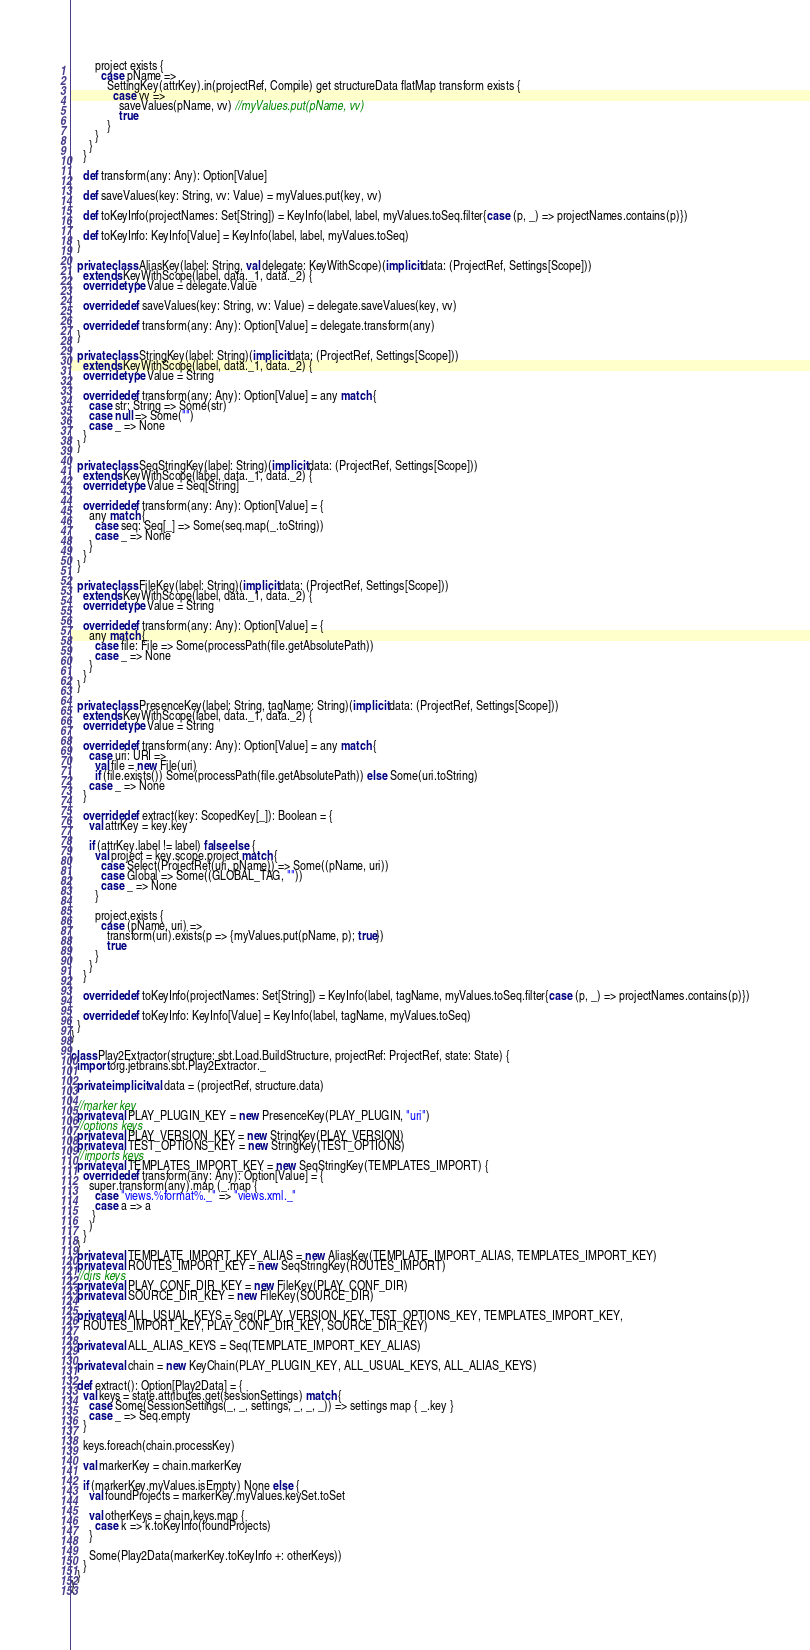<code> <loc_0><loc_0><loc_500><loc_500><_Scala_>
        project exists {
          case pName =>
            SettingKey(attrKey).in(projectRef, Compile) get structureData flatMap transform exists {
              case vv =>
                saveValues(pName, vv) //myValues.put(pName, vv)
                true
            }
        }
      }
    }

    def transform(any: Any): Option[Value]

    def saveValues(key: String, vv: Value) = myValues.put(key, vv)

    def toKeyInfo(projectNames: Set[String]) = KeyInfo(label, label, myValues.toSeq.filter{case (p, _) => projectNames.contains(p)})

    def toKeyInfo: KeyInfo[Value] = KeyInfo(label, label, myValues.toSeq)
  }

  private class AliasKey(label: String, val delegate: KeyWithScope)(implicit data: (ProjectRef, Settings[Scope]))
    extends KeyWithScope(label, data._1, data._2) {
    override type Value = delegate.Value

    override def saveValues(key: String, vv: Value) = delegate.saveValues(key, vv)

    override def transform(any: Any): Option[Value] = delegate.transform(any)
  }

  private class StringKey(label: String)(implicit data: (ProjectRef, Settings[Scope]))
    extends KeyWithScope(label, data._1, data._2) {
    override type Value = String

    override def transform(any: Any): Option[Value] = any match {
      case str: String => Some(str)
      case null => Some("")
      case _ => None
    }
  }

  private class SeqStringKey(label: String)(implicit data: (ProjectRef, Settings[Scope]))
    extends KeyWithScope(label, data._1, data._2) {
    override type Value = Seq[String]

    override def transform(any: Any): Option[Value] = {
      any match {
        case seq: Seq[_] => Some(seq.map(_.toString))
        case _ => None
      }
    }
  }

  private class FileKey(label: String)(implicit data: (ProjectRef, Settings[Scope]))
    extends KeyWithScope(label, data._1, data._2) {
    override type Value = String

    override def transform(any: Any): Option[Value] = {
      any match {
        case file: File => Some(processPath(file.getAbsolutePath))
        case _ => None
      }
    }
  }

  private class PresenceKey(label: String, tagName: String)(implicit data: (ProjectRef, Settings[Scope]))
    extends KeyWithScope(label, data._1, data._2) {
    override type Value = String

    override def transform(any: Any): Option[Value] = any match {
      case uri: URI =>
        val file = new File(uri)
        if (file.exists()) Some(processPath(file.getAbsolutePath)) else Some(uri.toString)
      case _ => None
    }

    override def extract(key: ScopedKey[_]): Boolean = {
      val attrKey = key.key

      if (attrKey.label != label) false else {
        val project = key.scope.project match {
          case Select(ProjectRef(uri, pName)) => Some((pName, uri))
          case Global => Some((GLOBAL_TAG, ""))
          case _ => None
        }

        project.exists {
          case (pName, uri) =>
            transform(uri).exists(p => {myValues.put(pName, p); true})
            true
        }
      }
    }

    override def toKeyInfo(projectNames: Set[String]) = KeyInfo(label, tagName, myValues.toSeq.filter{case (p, _) => projectNames.contains(p)})

    override def toKeyInfo: KeyInfo[Value] = KeyInfo(label, tagName, myValues.toSeq)
  }
}

class Play2Extractor(structure: sbt.Load.BuildStructure, projectRef: ProjectRef, state: State) {
  import org.jetbrains.sbt.Play2Extractor._

  private implicit val data = (projectRef, structure.data)

  //marker key
  private val PLAY_PLUGIN_KEY = new PresenceKey(PLAY_PLUGIN, "uri")
  //options keys
  private val PLAY_VERSION_KEY = new StringKey(PLAY_VERSION)
  private val TEST_OPTIONS_KEY = new StringKey(TEST_OPTIONS)
  //imports keys
  private val TEMPLATES_IMPORT_KEY = new SeqStringKey(TEMPLATES_IMPORT) {
    override def transform(any: Any): Option[Value] = {
      super.transform(any).map (_.map {
        case "views.%format%._" => "views.xml._"
        case a => a
       }
      )
    }
  }
  private val TEMPLATE_IMPORT_KEY_ALIAS = new AliasKey(TEMPLATE_IMPORT_ALIAS, TEMPLATES_IMPORT_KEY)
  private val ROUTES_IMPORT_KEY = new SeqStringKey(ROUTES_IMPORT)
  //dirs keys
  private val PLAY_CONF_DIR_KEY = new FileKey(PLAY_CONF_DIR)
  private val SOURCE_DIR_KEY = new FileKey(SOURCE_DIR)

  private val ALL_USUAL_KEYS = Seq(PLAY_VERSION_KEY, TEST_OPTIONS_KEY, TEMPLATES_IMPORT_KEY,
    ROUTES_IMPORT_KEY, PLAY_CONF_DIR_KEY, SOURCE_DIR_KEY)

  private val ALL_ALIAS_KEYS = Seq(TEMPLATE_IMPORT_KEY_ALIAS)

  private val chain = new KeyChain(PLAY_PLUGIN_KEY, ALL_USUAL_KEYS, ALL_ALIAS_KEYS)

  def extract(): Option[Play2Data] = {
    val keys = state.attributes.get(sessionSettings) match {
      case Some(SessionSettings(_, _, settings, _, _, _)) => settings map { _.key }
      case _ => Seq.empty
    }

    keys.foreach(chain.processKey)

    val markerKey = chain.markerKey

    if (markerKey.myValues.isEmpty) None else {
      val foundProjects = markerKey.myValues.keySet.toSet

      val otherKeys = chain.keys.map {
        case k => k.toKeyInfo(foundProjects)
      }

      Some(Play2Data(markerKey.toKeyInfo +: otherKeys))
    }
  }
}
</code> 